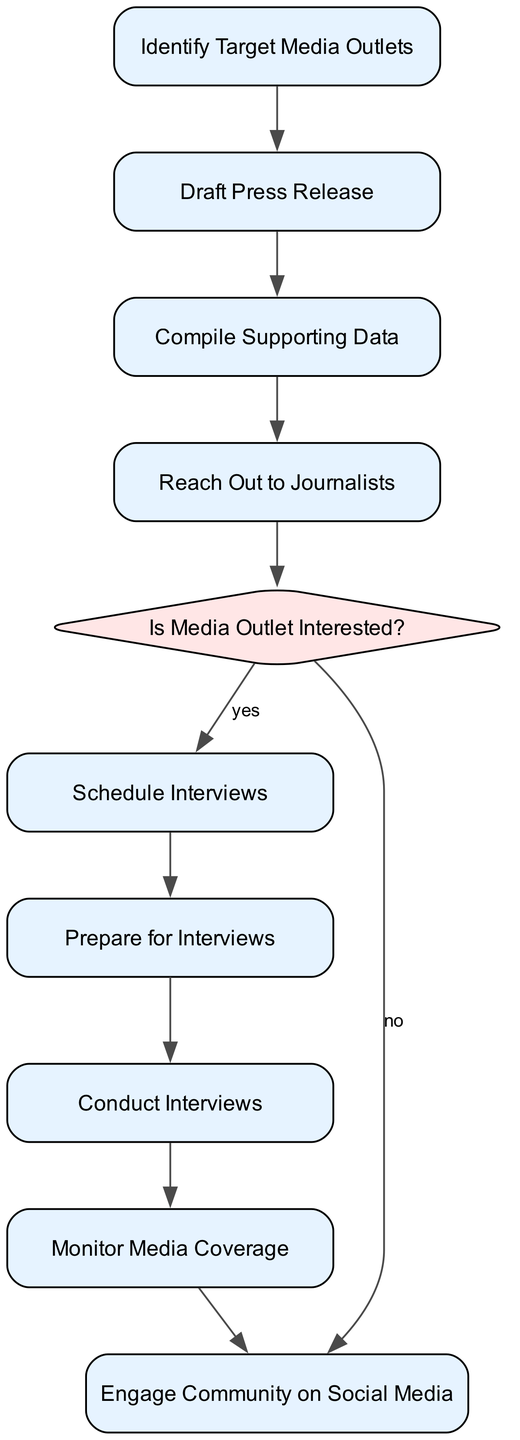What is the first activity listed in the diagram? The first activity listed is "Identify Target Media Outlets," which means it is the initial action that must be completed before any others.
Answer: Identify Target Media Outlets How many activities are in the diagram? Counting the activities listed in the diagram, there are a total of 9 activities presented.
Answer: 9 What decision point is in the diagram? The decision point present in the diagram is "Is Media Outlet Interested?" which determines the subsequent flow based on the interest level of the media outlet.
Answer: Is Media Outlet Interested? What happens if the media outlet is not interested? If the media outlet is not interested, the flow goes to "Engage Community on Social Media," allowing the community organizer to focus on social media outreach instead of interviews.
Answer: Engage Community on Social Media Which activity comes after "Reach Out to Journalists"? After "Reach Out to Journalists," the next activity is determined by the decision point, specifically it goes to "Is Media Outlet Interested?" depending on the media outlet's interest.
Answer: Is Media Outlet Interested? What is the last activity in the diagram? The last activity in the diagram is "Engage Community on Social Media," which concludes the flow by promoting the media coverage via social platforms.
Answer: Engage Community on Social Media What is the condition for scheduling interviews? The condition for scheduling interviews is a "yes" response from the decision point "Is Media Outlet Interested?" indicating that the outlet is indeed interested in the story.
Answer: yes Which two activities are connected directly? One connected pair of activities is "Prepare for Interviews" and "Conduct Interviews," flowing directly between each other in the process of media engagement.
Answer: Prepare for Interviews and Conduct Interviews What is the purpose of "Compile Supporting Data"? The purpose of "Compile Supporting Data" is to gather essential information on resource allocation issues and community needs, serving as the foundation for the press release.
Answer: Gather data on resource allocation issues, community needs, and alternative uses of the funds 